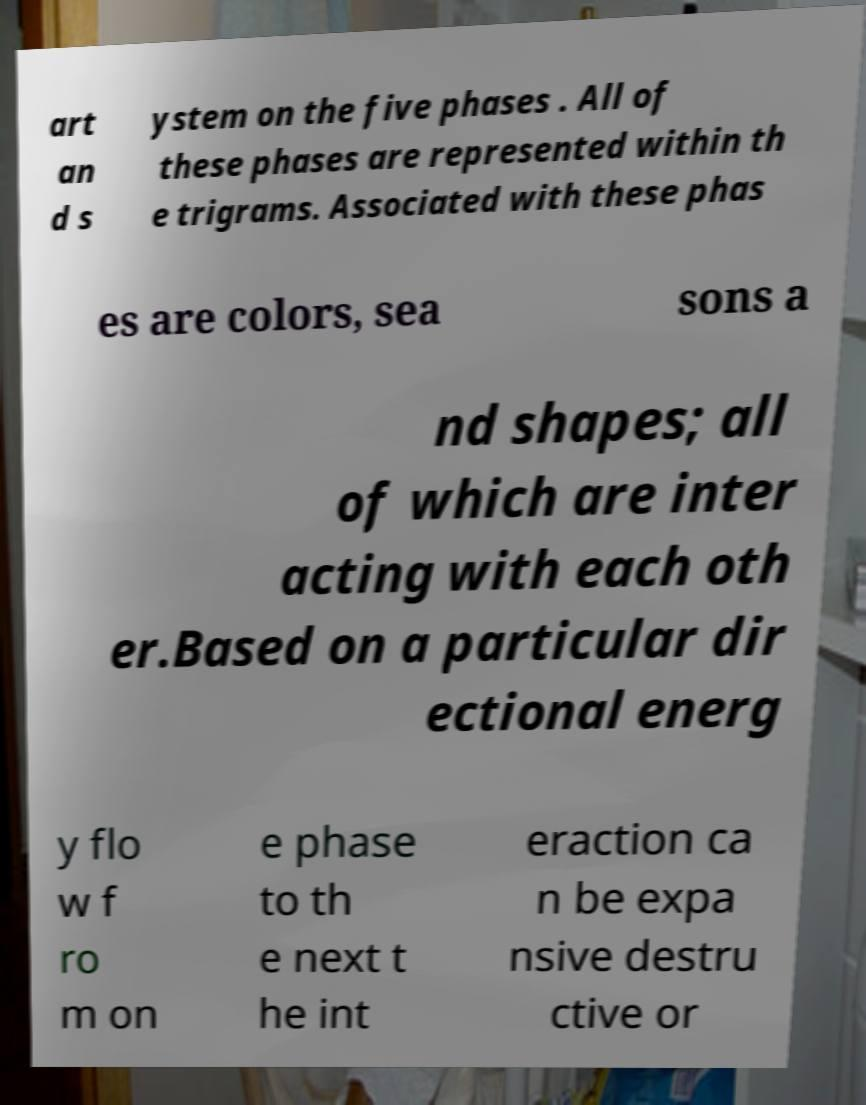What messages or text are displayed in this image? I need them in a readable, typed format. art an d s ystem on the five phases . All of these phases are represented within th e trigrams. Associated with these phas es are colors, sea sons a nd shapes; all of which are inter acting with each oth er.Based on a particular dir ectional energ y flo w f ro m on e phase to th e next t he int eraction ca n be expa nsive destru ctive or 